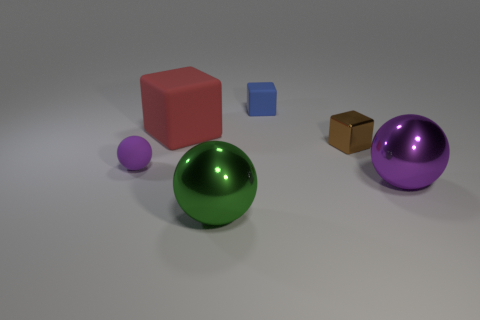Subtract all matte cubes. How many cubes are left? 1 Add 2 large red metal cubes. How many objects exist? 8 Subtract all green spheres. How many spheres are left? 2 Subtract all large red things. Subtract all big green shiny spheres. How many objects are left? 4 Add 1 big green objects. How many big green objects are left? 2 Add 2 red blocks. How many red blocks exist? 3 Subtract 0 red balls. How many objects are left? 6 Subtract 1 cubes. How many cubes are left? 2 Subtract all blue cubes. Subtract all purple cylinders. How many cubes are left? 2 Subtract all purple cylinders. How many gray cubes are left? 0 